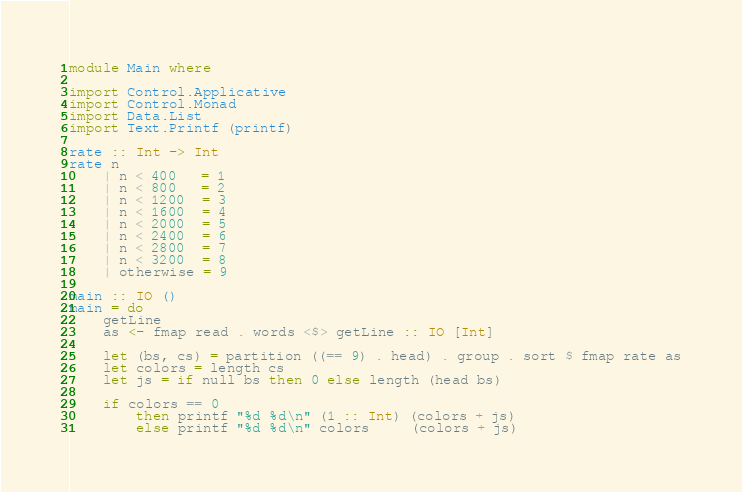Convert code to text. <code><loc_0><loc_0><loc_500><loc_500><_Haskell_>module Main where

import Control.Applicative
import Control.Monad
import Data.List
import Text.Printf (printf)

rate :: Int -> Int
rate n
    | n < 400   = 1
    | n < 800   = 2
    | n < 1200  = 3
    | n < 1600  = 4
    | n < 2000  = 5
    | n < 2400  = 6
    | n < 2800  = 7
    | n < 3200  = 8
    | otherwise = 9

main :: IO ()
main = do
    getLine
    as <- fmap read . words <$> getLine :: IO [Int]

    let (bs, cs) = partition ((== 9) . head) . group . sort $ fmap rate as
    let colors = length cs
    let js = if null bs then 0 else length (head bs)

    if colors == 0
        then printf "%d %d\n" (1 :: Int) (colors + js)
        else printf "%d %d\n" colors     (colors + js)</code> 